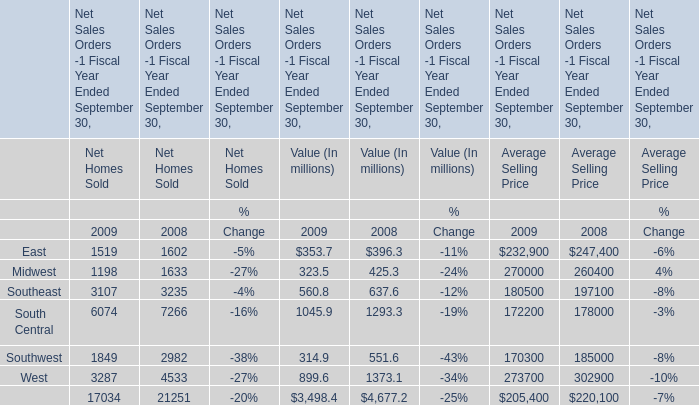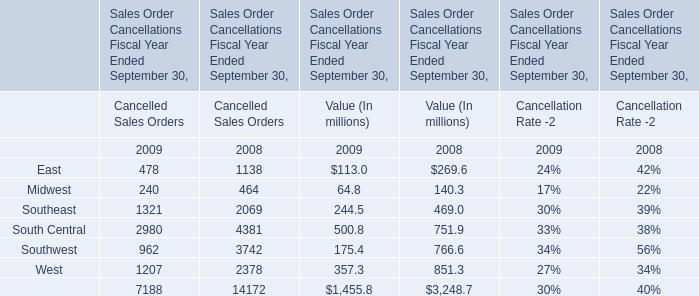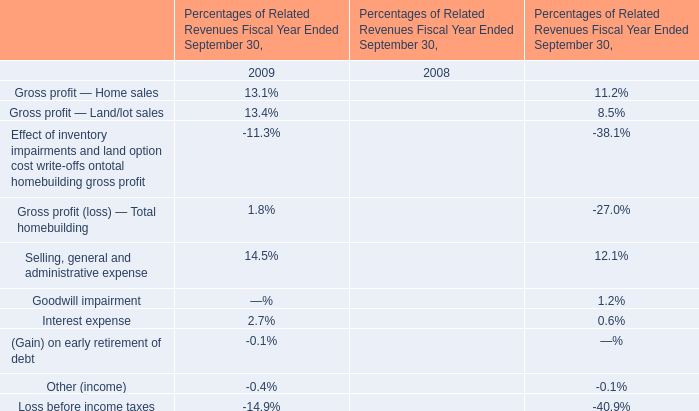Which year is Midwest for Value (In millions) the lowest? 
Answer: 2009. 